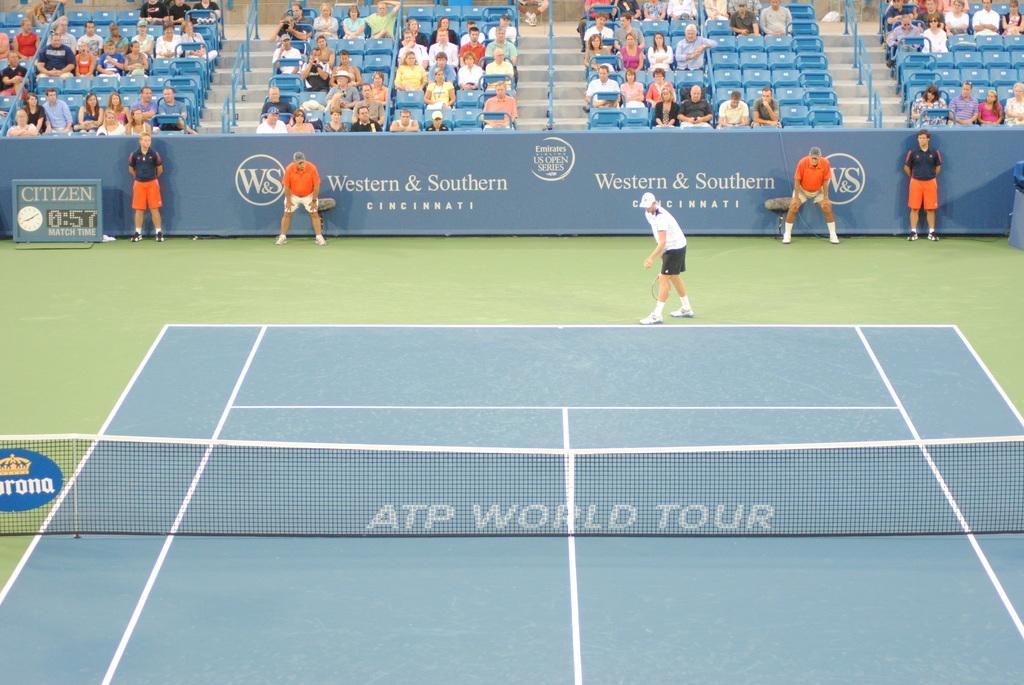Could you give a brief overview of what you see in this image? There is a tennis court with net. A person wearing cap is holding a tennis racket. In the back there is a wall with banner. Also few people are standing. On the left side there is a screen with clock and time. In the background there are many people sitting on chairs. Also there are steps with railings. 